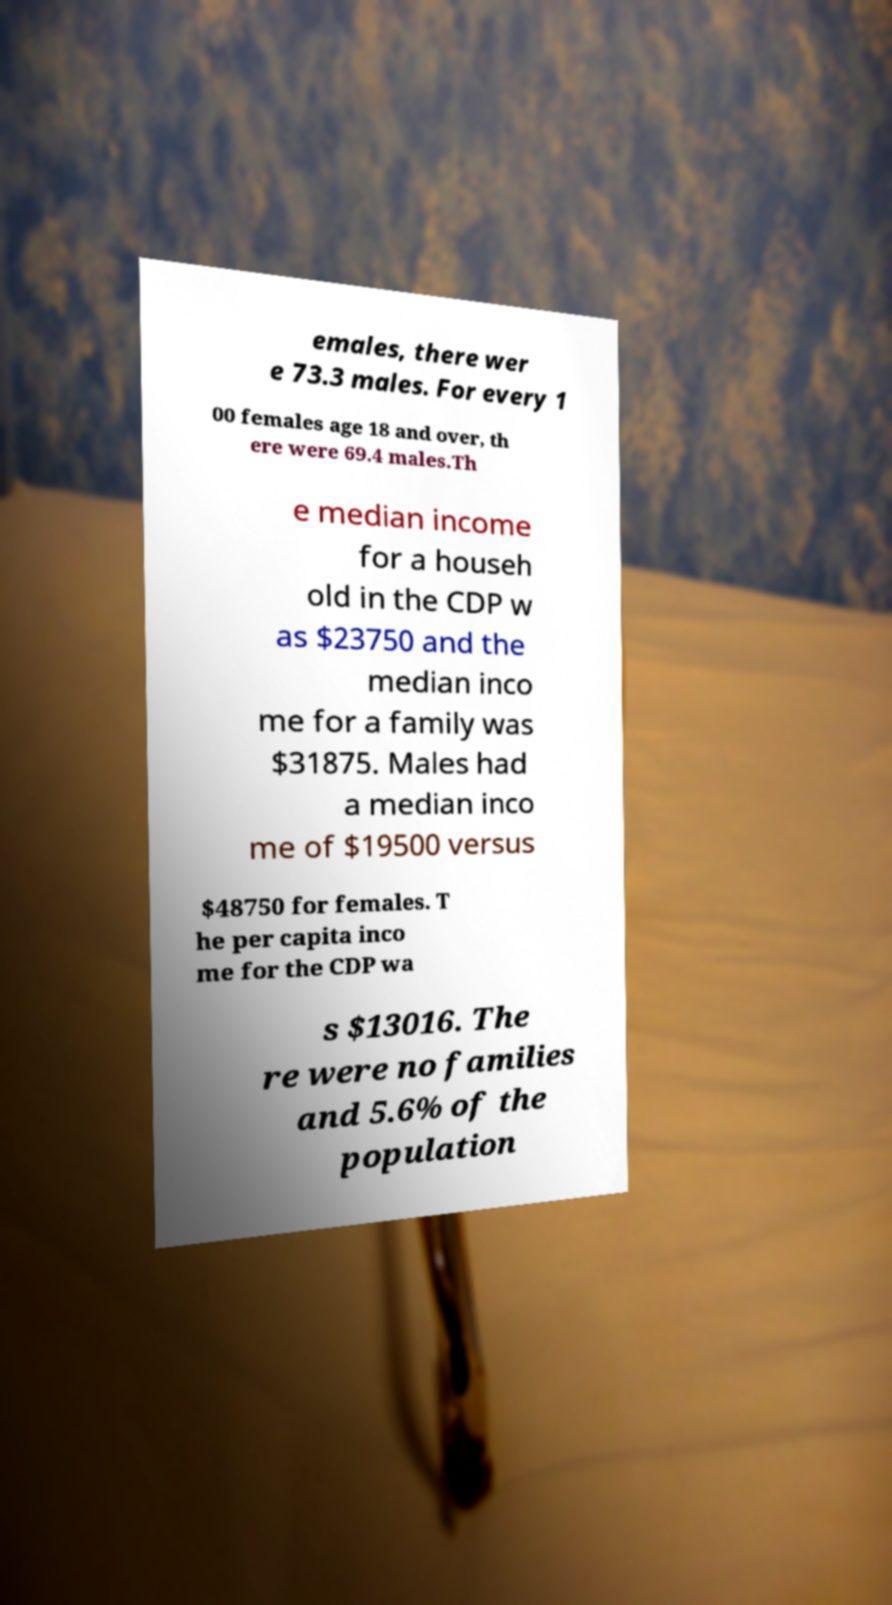For documentation purposes, I need the text within this image transcribed. Could you provide that? emales, there wer e 73.3 males. For every 1 00 females age 18 and over, th ere were 69.4 males.Th e median income for a househ old in the CDP w as $23750 and the median inco me for a family was $31875. Males had a median inco me of $19500 versus $48750 for females. T he per capita inco me for the CDP wa s $13016. The re were no families and 5.6% of the population 